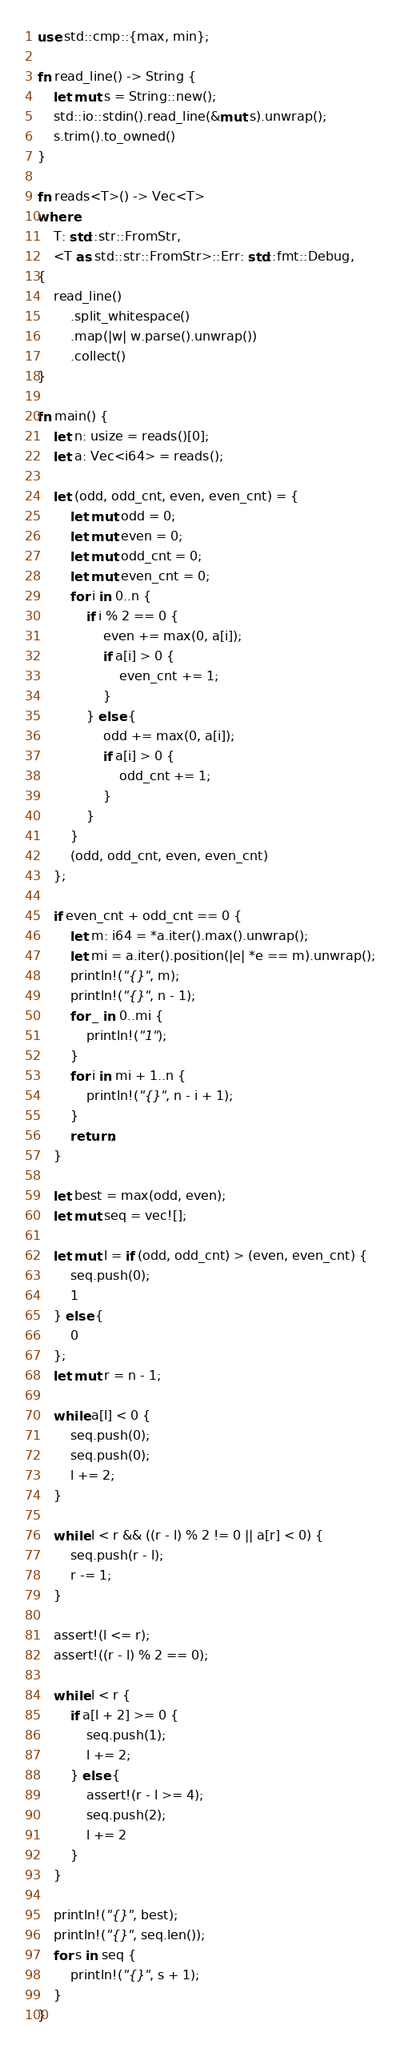<code> <loc_0><loc_0><loc_500><loc_500><_Rust_>use std::cmp::{max, min};

fn read_line() -> String {
    let mut s = String::new();
    std::io::stdin().read_line(&mut s).unwrap();
    s.trim().to_owned()
}

fn reads<T>() -> Vec<T>
where
    T: std::str::FromStr,
    <T as std::str::FromStr>::Err: std::fmt::Debug,
{
    read_line()
        .split_whitespace()
        .map(|w| w.parse().unwrap())
        .collect()
}

fn main() {
    let n: usize = reads()[0];
    let a: Vec<i64> = reads();

    let (odd, odd_cnt, even, even_cnt) = {
        let mut odd = 0;
        let mut even = 0;
        let mut odd_cnt = 0;
        let mut even_cnt = 0;
        for i in 0..n {
            if i % 2 == 0 {
                even += max(0, a[i]);
                if a[i] > 0 {
                    even_cnt += 1;
                }
            } else {
                odd += max(0, a[i]);
                if a[i] > 0 {
                    odd_cnt += 1;
                }
            }
        }
        (odd, odd_cnt, even, even_cnt)
    };

    if even_cnt + odd_cnt == 0 {
        let m: i64 = *a.iter().max().unwrap();
        let mi = a.iter().position(|e| *e == m).unwrap();
        println!("{}", m);
        println!("{}", n - 1);
        for _ in 0..mi {
            println!("1");
        }
        for i in mi + 1..n {
            println!("{}", n - i + 1);
        }
        return;
    }

    let best = max(odd, even);
    let mut seq = vec![];

    let mut l = if (odd, odd_cnt) > (even, even_cnt) {
        seq.push(0);
        1
    } else {
        0
    };
    let mut r = n - 1;

    while a[l] < 0 {
        seq.push(0);
        seq.push(0);
        l += 2;
    }

    while l < r && ((r - l) % 2 != 0 || a[r] < 0) {
        seq.push(r - l);
        r -= 1;
    }

    assert!(l <= r);
    assert!((r - l) % 2 == 0);

    while l < r {
        if a[l + 2] >= 0 {
            seq.push(1);
            l += 2;
        } else {
            assert!(r - l >= 4);
            seq.push(2);
            l += 2
        }
    }

    println!("{}", best);
    println!("{}", seq.len());
    for s in seq {
        println!("{}", s + 1);
    }
}
</code> 